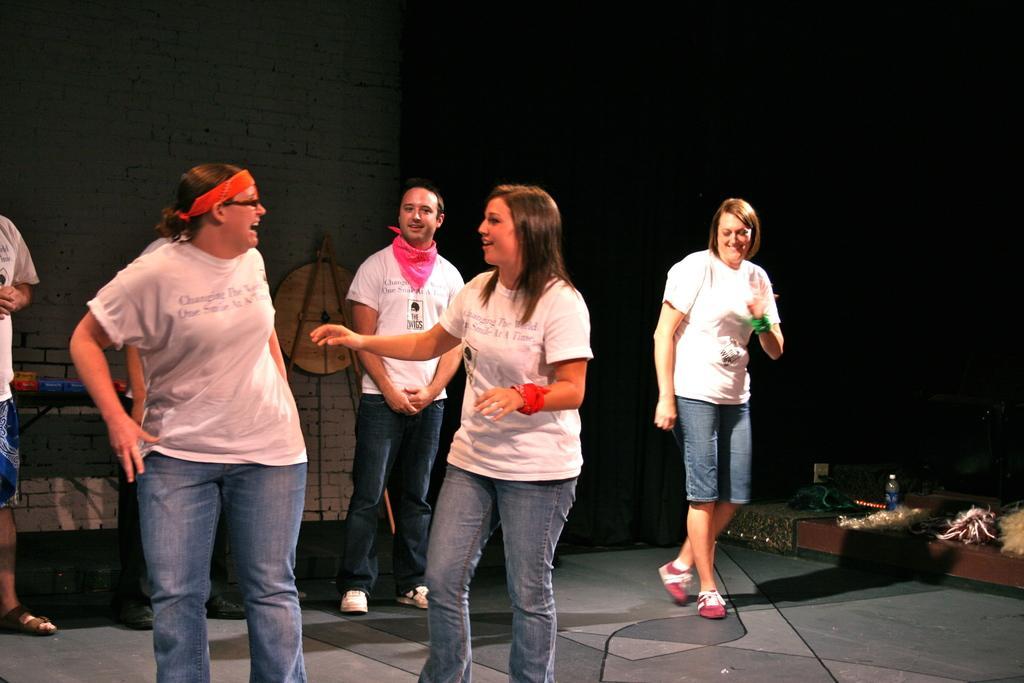Could you give a brief overview of what you see in this image? In this image we can see a few people standing, in the right hand corner we can see few objects, we can see the brick wall in the background, few objects on a table, beside that we can see an object. 